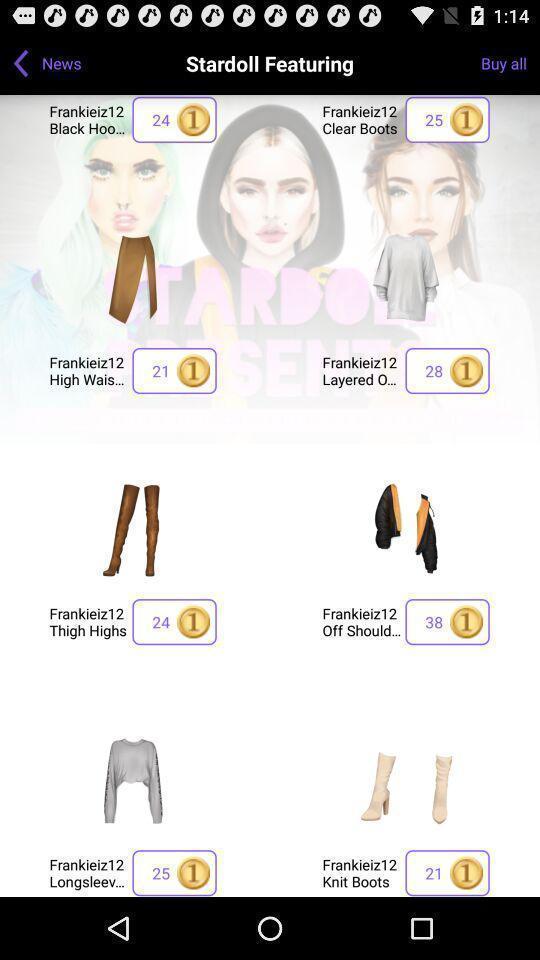Explain what's happening in this screen capture. Page displaying the different products. 